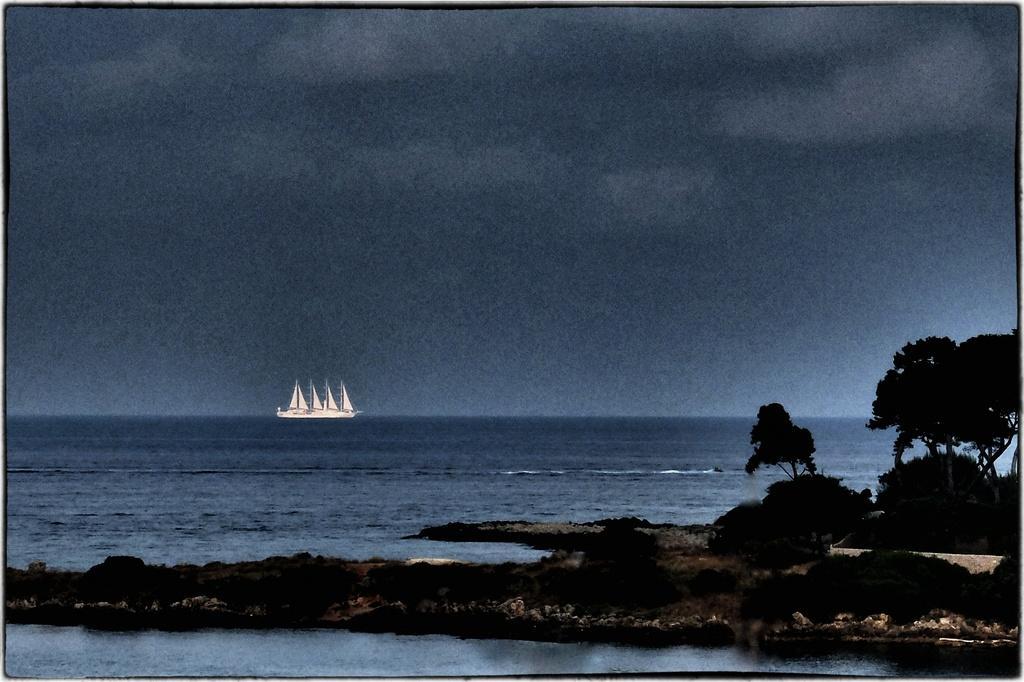How would you summarize this image in a sentence or two? We can see water and trees. A far we can see ship and we can see sky. 